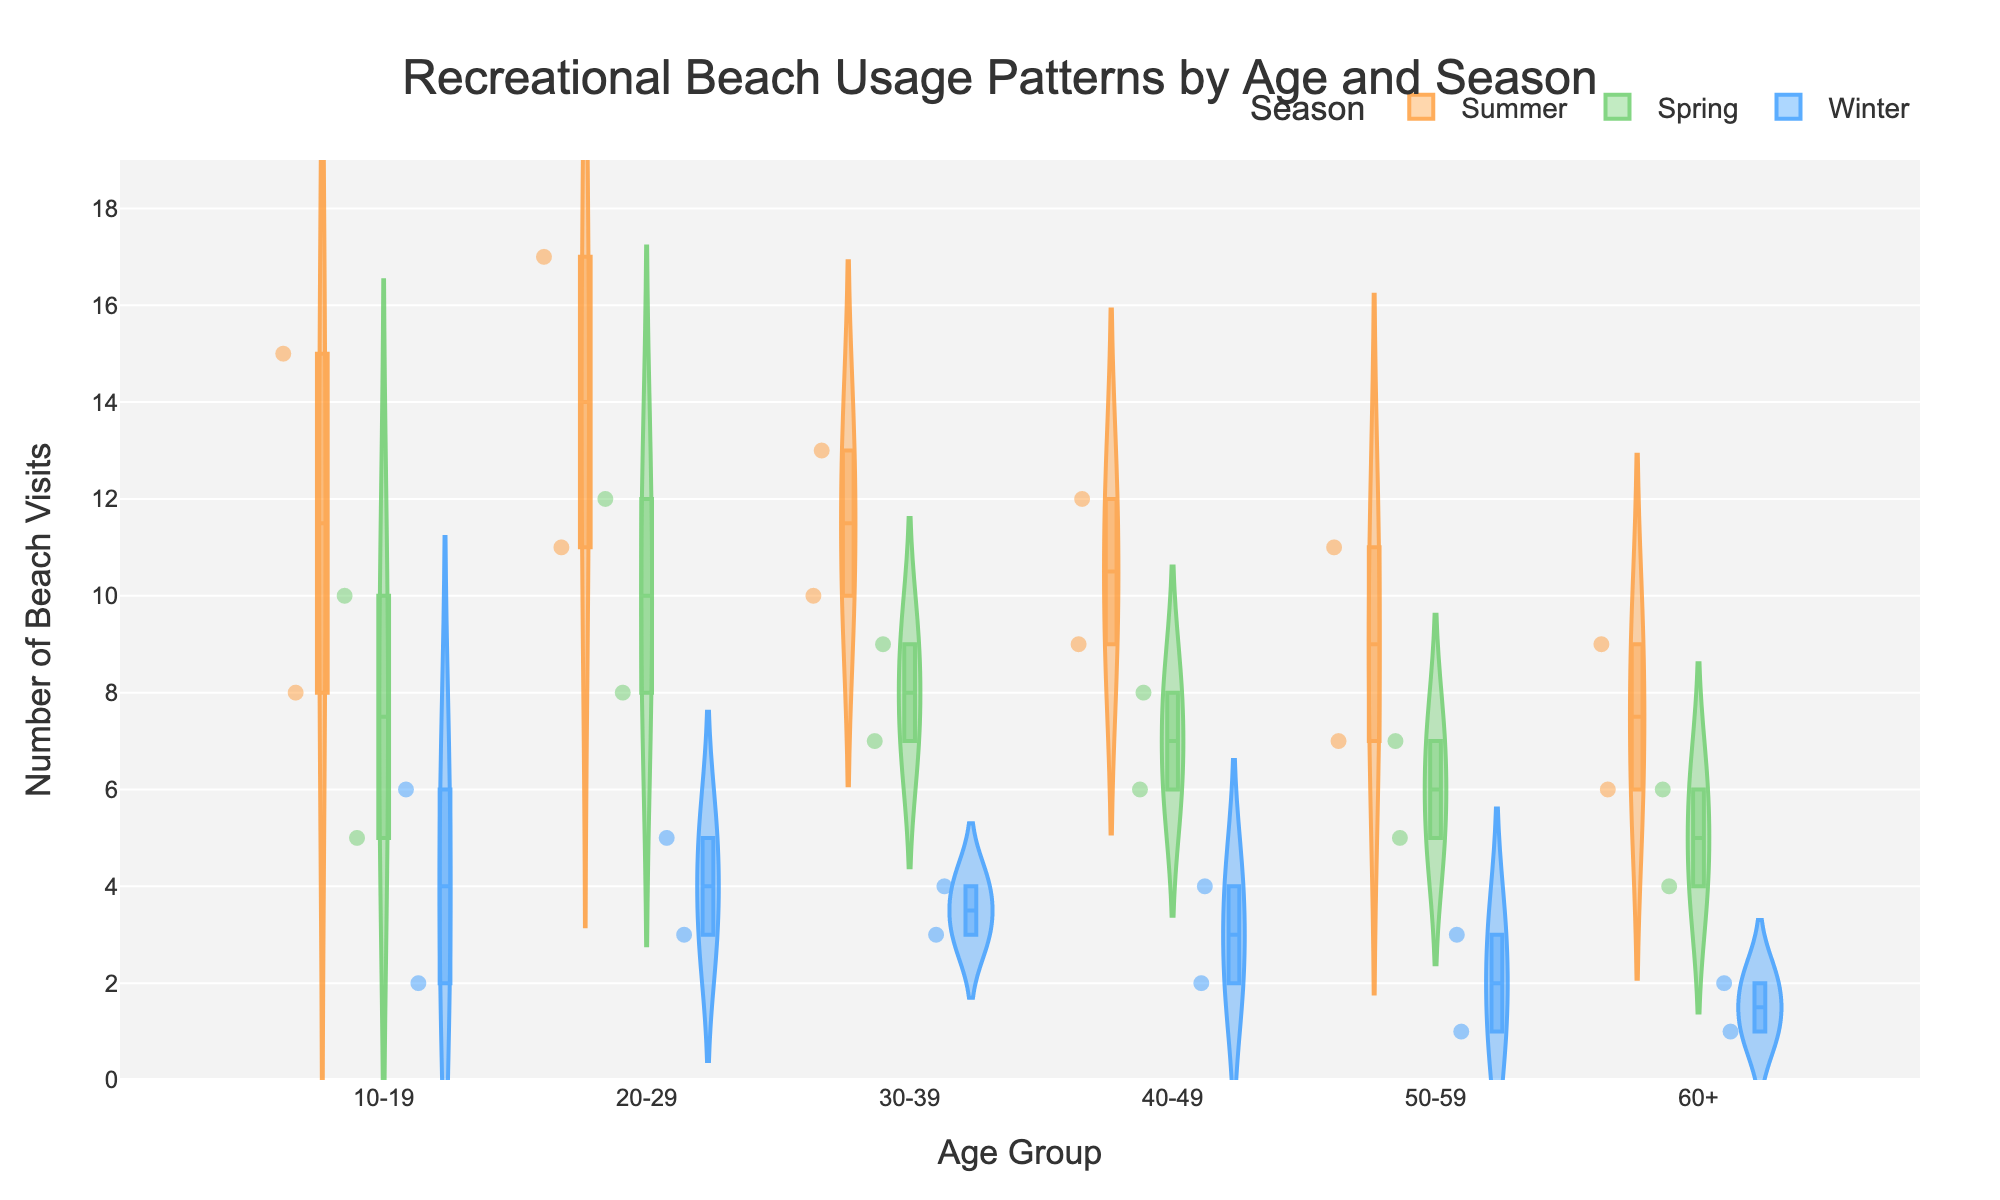What's the age group with the highest number of beach visits in summer? To find this, look at the highest point in the violin plot for each age group during summer. The age group 20-29 has the highest number of beach visits in summer, reaching up to 17 visits.
Answer: 20-29 During which season do the 10-19 age group's beach visits exhibit the highest variability? Examine the spread of the violin plots for the 10-19 age group. The summer season shows the widest distribution of beach visits, indicating the highest variability.
Answer: Summer What is the median number of beach visits for the 30-39 age group in spring? Look at the box plot inside the spring violin plot for the 30-39 age group. The median is marked by the line inside the box plot, which is at 8 visits.
Answer: 8 For the 60+ age group, how do the median beach visits compare between summer and winter? Compare the median lines in the summer and winter violin plots for the 60+ age group. The median in summer is 7.5, while in winter it is 1.5, showing that summer is higher.
Answer: Summer is higher In spring, which age group has the highest median number of beach visits? Look at the median lines in the spring violin plots for all age groups. The 20-29 and 30-39 age groups both have a median of 8 beach visits, which is the highest in spring.
Answer: 20-29 and 30-39 Which age group has the smallest number of beach visits during winter? Identify the lowest point in the winter violin plots for all age groups. The 50-59 and 60+ age groups both have a lowest point of 1 visit.
Answer: 50-59 and 60+ How do the distributions of beach visits compare between the 40-49 and 50-59 age groups in spring? Compare the spreads and shapes of the violin plots for the 40-49 and 50-59 age groups in spring. Both distributions are quite similar, showing a narrow range between 5 to 8 visits.
Answer: Similar In which season do the 20-29 age group's beach visits have the least variability? Compare the spreads of the violin plots for the 20-29 age group across all seasons. The winter season shows the least spread, indicating the least variability.
Answer: Winter What pattern can be observed for beach visit trends across all age groups in winter? Look at all the violin plots for winter. All age groups show a lower number of beach visits with narrow distributions, indicating less frequent visits during winter.
Answer: Lower and less frequent 